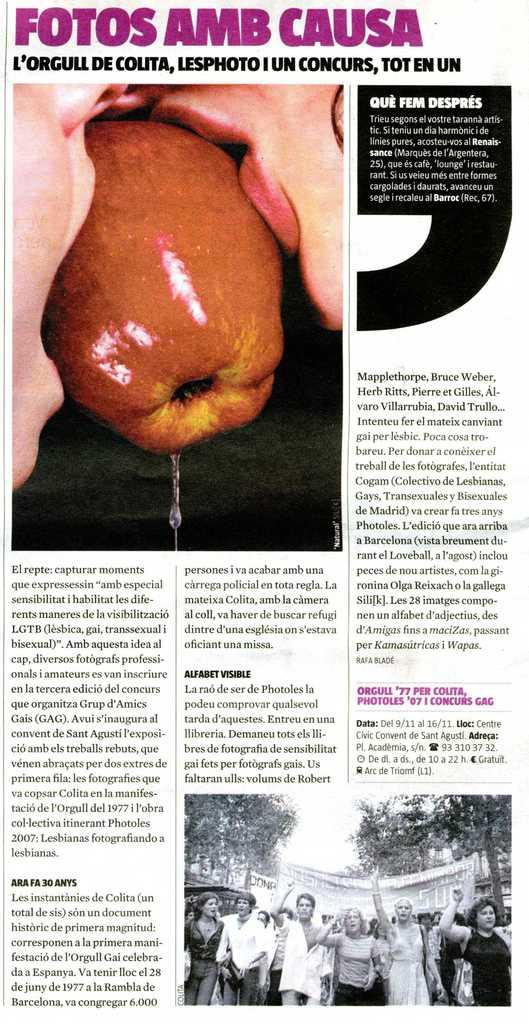Provide a one-sentence caption for the provided image. a foreign newspaper page full of articles and pictures. 